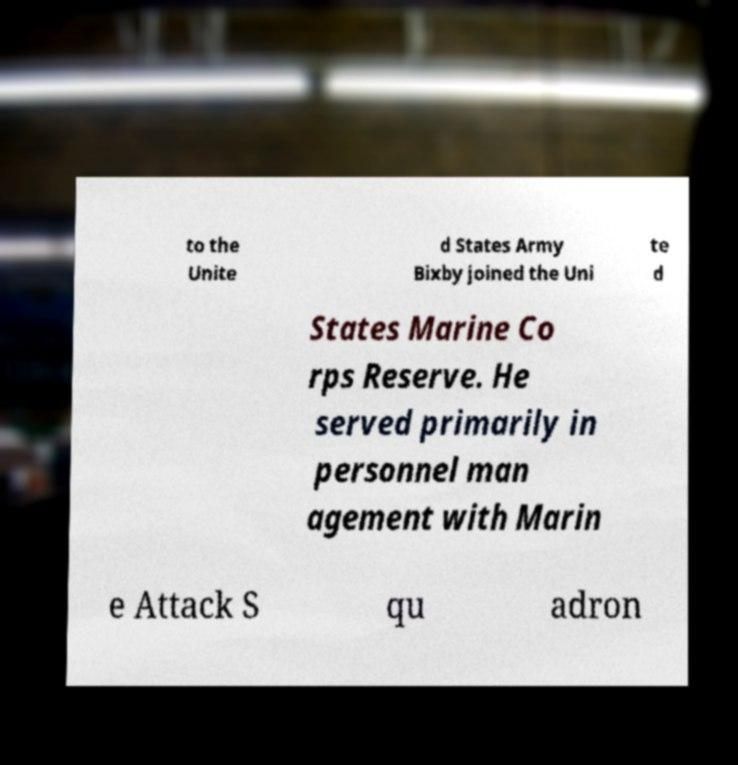I need the written content from this picture converted into text. Can you do that? to the Unite d States Army Bixby joined the Uni te d States Marine Co rps Reserve. He served primarily in personnel man agement with Marin e Attack S qu adron 